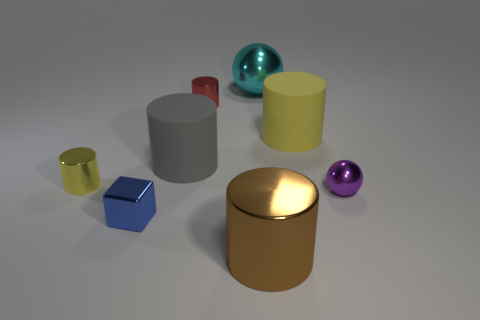What color is the sphere that is the same size as the shiny block?
Ensure brevity in your answer.  Purple. Is there a small shiny thing of the same color as the large shiny cylinder?
Offer a terse response. No. Are there any big cylinders?
Provide a succinct answer. Yes. What is the shape of the large thing right of the cyan thing?
Your answer should be very brief. Cylinder. What number of yellow cylinders are both on the left side of the cyan metal sphere and on the right side of the tiny blue metal block?
Offer a terse response. 0. How many other things are the same size as the gray matte object?
Offer a very short reply. 3. There is a cyan object on the right side of the tiny red metal object; is it the same shape as the tiny metallic object that is behind the yellow metallic cylinder?
Give a very brief answer. No. What number of objects are small metal balls or small metallic cylinders left of the blue metal block?
Provide a succinct answer. 2. The object that is in front of the large yellow thing and to the right of the large cyan object is made of what material?
Offer a very short reply. Metal. Is there any other thing that is the same shape as the large yellow object?
Keep it short and to the point. Yes. 